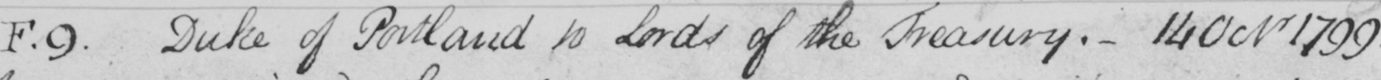Please provide the text content of this handwritten line. F.9 Duke of Portland to Lords of the Treasury .  _  14 Octr 1799 . 